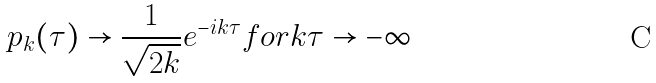Convert formula to latex. <formula><loc_0><loc_0><loc_500><loc_500>p _ { k } ( \tau ) \rightarrow \frac { 1 } { \sqrt { 2 k } } e ^ { - i k \tau } f o r k \tau \rightarrow - \infty</formula> 